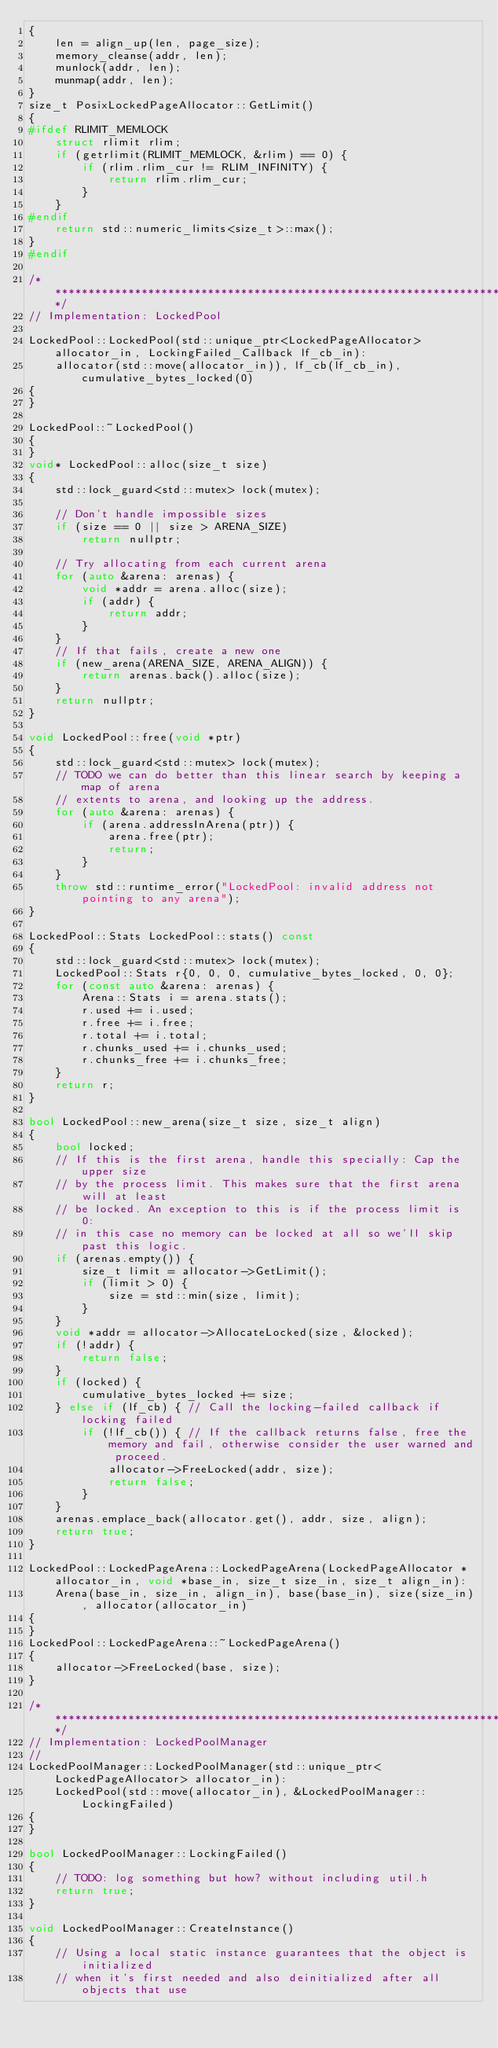<code> <loc_0><loc_0><loc_500><loc_500><_C++_>{
    len = align_up(len, page_size);
    memory_cleanse(addr, len);
    munlock(addr, len);
    munmap(addr, len);
}
size_t PosixLockedPageAllocator::GetLimit()
{
#ifdef RLIMIT_MEMLOCK
    struct rlimit rlim;
    if (getrlimit(RLIMIT_MEMLOCK, &rlim) == 0) {
        if (rlim.rlim_cur != RLIM_INFINITY) {
            return rlim.rlim_cur;
        }
    }
#endif
    return std::numeric_limits<size_t>::max();
}
#endif

/*******************************************************************************/
// Implementation: LockedPool

LockedPool::LockedPool(std::unique_ptr<LockedPageAllocator> allocator_in, LockingFailed_Callback lf_cb_in):
    allocator(std::move(allocator_in)), lf_cb(lf_cb_in), cumulative_bytes_locked(0)
{
}

LockedPool::~LockedPool()
{
}
void* LockedPool::alloc(size_t size)
{
    std::lock_guard<std::mutex> lock(mutex);

    // Don't handle impossible sizes
    if (size == 0 || size > ARENA_SIZE)
        return nullptr;

    // Try allocating from each current arena
    for (auto &arena: arenas) {
        void *addr = arena.alloc(size);
        if (addr) {
            return addr;
        }
    }
    // If that fails, create a new one
    if (new_arena(ARENA_SIZE, ARENA_ALIGN)) {
        return arenas.back().alloc(size);
    }
    return nullptr;
}

void LockedPool::free(void *ptr)
{
    std::lock_guard<std::mutex> lock(mutex);
    // TODO we can do better than this linear search by keeping a map of arena
    // extents to arena, and looking up the address.
    for (auto &arena: arenas) {
        if (arena.addressInArena(ptr)) {
            arena.free(ptr);
            return;
        }
    }
    throw std::runtime_error("LockedPool: invalid address not pointing to any arena");
}

LockedPool::Stats LockedPool::stats() const
{
    std::lock_guard<std::mutex> lock(mutex);
    LockedPool::Stats r{0, 0, 0, cumulative_bytes_locked, 0, 0};
    for (const auto &arena: arenas) {
        Arena::Stats i = arena.stats();
        r.used += i.used;
        r.free += i.free;
        r.total += i.total;
        r.chunks_used += i.chunks_used;
        r.chunks_free += i.chunks_free;
    }
    return r;
}

bool LockedPool::new_arena(size_t size, size_t align)
{
    bool locked;
    // If this is the first arena, handle this specially: Cap the upper size
    // by the process limit. This makes sure that the first arena will at least
    // be locked. An exception to this is if the process limit is 0:
    // in this case no memory can be locked at all so we'll skip past this logic.
    if (arenas.empty()) {
        size_t limit = allocator->GetLimit();
        if (limit > 0) {
            size = std::min(size, limit);
        }
    }
    void *addr = allocator->AllocateLocked(size, &locked);
    if (!addr) {
        return false;
    }
    if (locked) {
        cumulative_bytes_locked += size;
    } else if (lf_cb) { // Call the locking-failed callback if locking failed
        if (!lf_cb()) { // If the callback returns false, free the memory and fail, otherwise consider the user warned and proceed.
            allocator->FreeLocked(addr, size);
            return false;
        }
    }
    arenas.emplace_back(allocator.get(), addr, size, align);
    return true;
}

LockedPool::LockedPageArena::LockedPageArena(LockedPageAllocator *allocator_in, void *base_in, size_t size_in, size_t align_in):
    Arena(base_in, size_in, align_in), base(base_in), size(size_in), allocator(allocator_in)
{
}
LockedPool::LockedPageArena::~LockedPageArena()
{
    allocator->FreeLocked(base, size);
}

/*******************************************************************************/
// Implementation: LockedPoolManager
//
LockedPoolManager::LockedPoolManager(std::unique_ptr<LockedPageAllocator> allocator_in):
    LockedPool(std::move(allocator_in), &LockedPoolManager::LockingFailed)
{
}

bool LockedPoolManager::LockingFailed()
{
    // TODO: log something but how? without including util.h
    return true;
}

void LockedPoolManager::CreateInstance()
{
    // Using a local static instance guarantees that the object is initialized
    // when it's first needed and also deinitialized after all objects that use</code> 